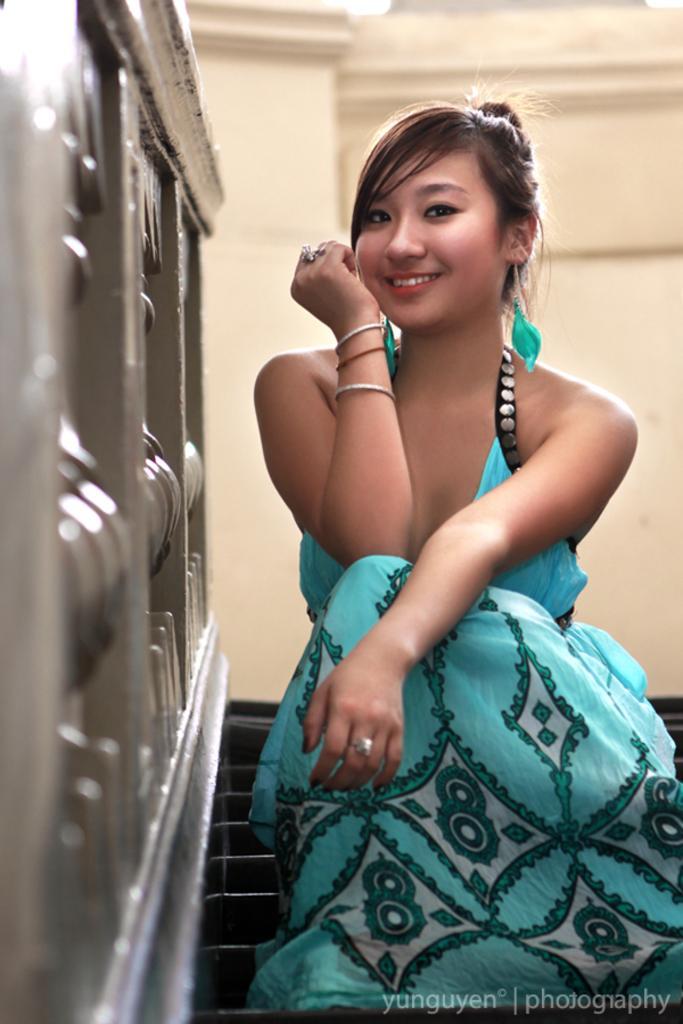Can you describe this image briefly? In the foreground I can see a woman on the steps and a text. In the background I can see a wall and metal rods. This image is taken may be during a day. 